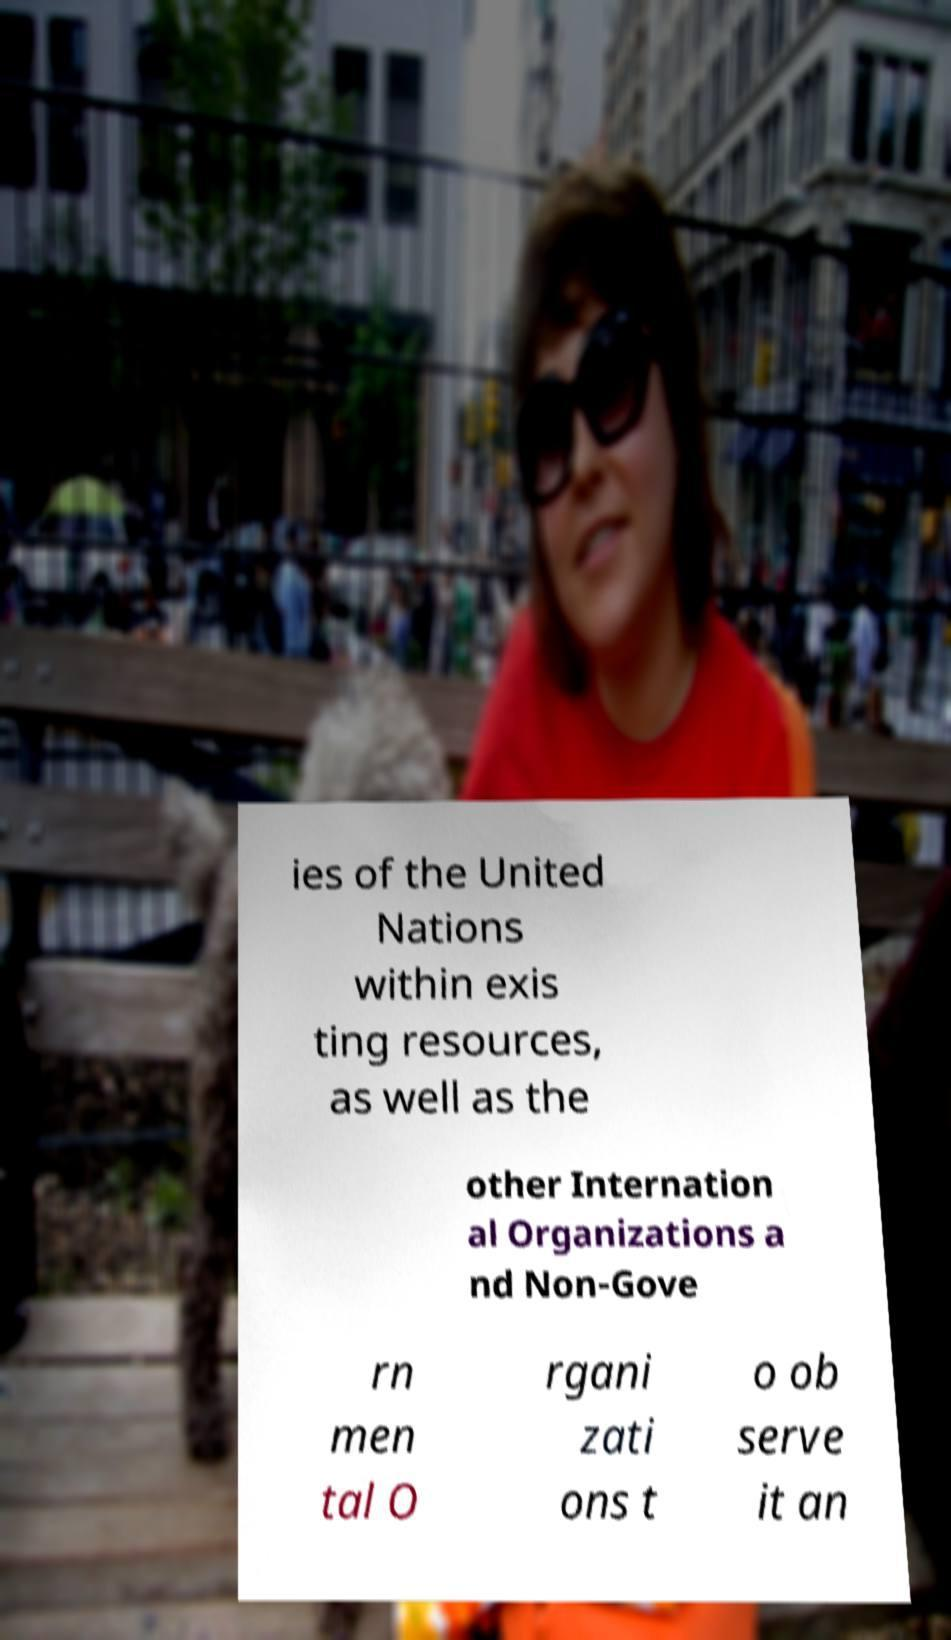Please read and relay the text visible in this image. What does it say? ies of the United Nations within exis ting resources, as well as the other Internation al Organizations a nd Non-Gove rn men tal O rgani zati ons t o ob serve it an 